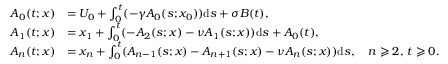Convert formula to latex. <formula><loc_0><loc_0><loc_500><loc_500>\begin{array} { r l } { A _ { 0 } ( t ; x ) } & { = U _ { 0 } + \int _ { 0 } ^ { t } ( - \gamma A _ { 0 } ( s ; x _ { 0 } ) ) d s + \sigma B ( t ) , } \\ { A _ { 1 } ( t ; x ) } & { = x _ { 1 } + \int _ { 0 } ^ { t } ( - A _ { 2 } ( s ; x ) - \nu A _ { 1 } ( s ; x ) ) d s + A _ { 0 } ( t ) , } \\ { A _ { n } ( t ; x ) } & { = x _ { n } + \int _ { 0 } ^ { t } ( { A _ { n - 1 } ( s ; x ) } - A _ { n + 1 } ( s ; x ) - \nu A _ { n } ( s ; x ) ) d s , \quad n \geqslant 2 , \, t \geqslant 0 . } \end{array}</formula> 